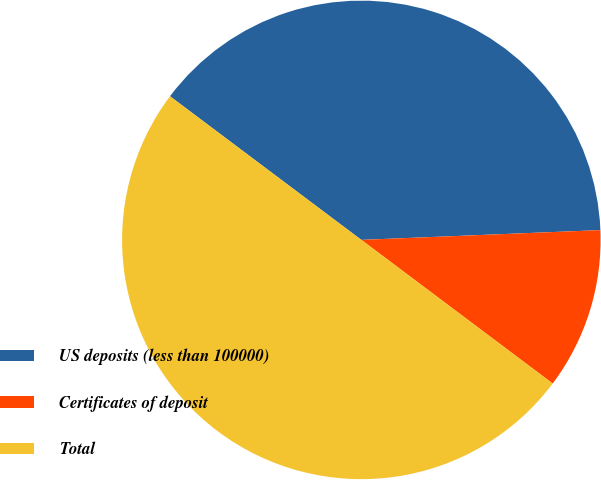Convert chart to OTSL. <chart><loc_0><loc_0><loc_500><loc_500><pie_chart><fcel>US deposits (less than 100000)<fcel>Certificates of deposit<fcel>Total<nl><fcel>39.1%<fcel>10.9%<fcel>50.0%<nl></chart> 